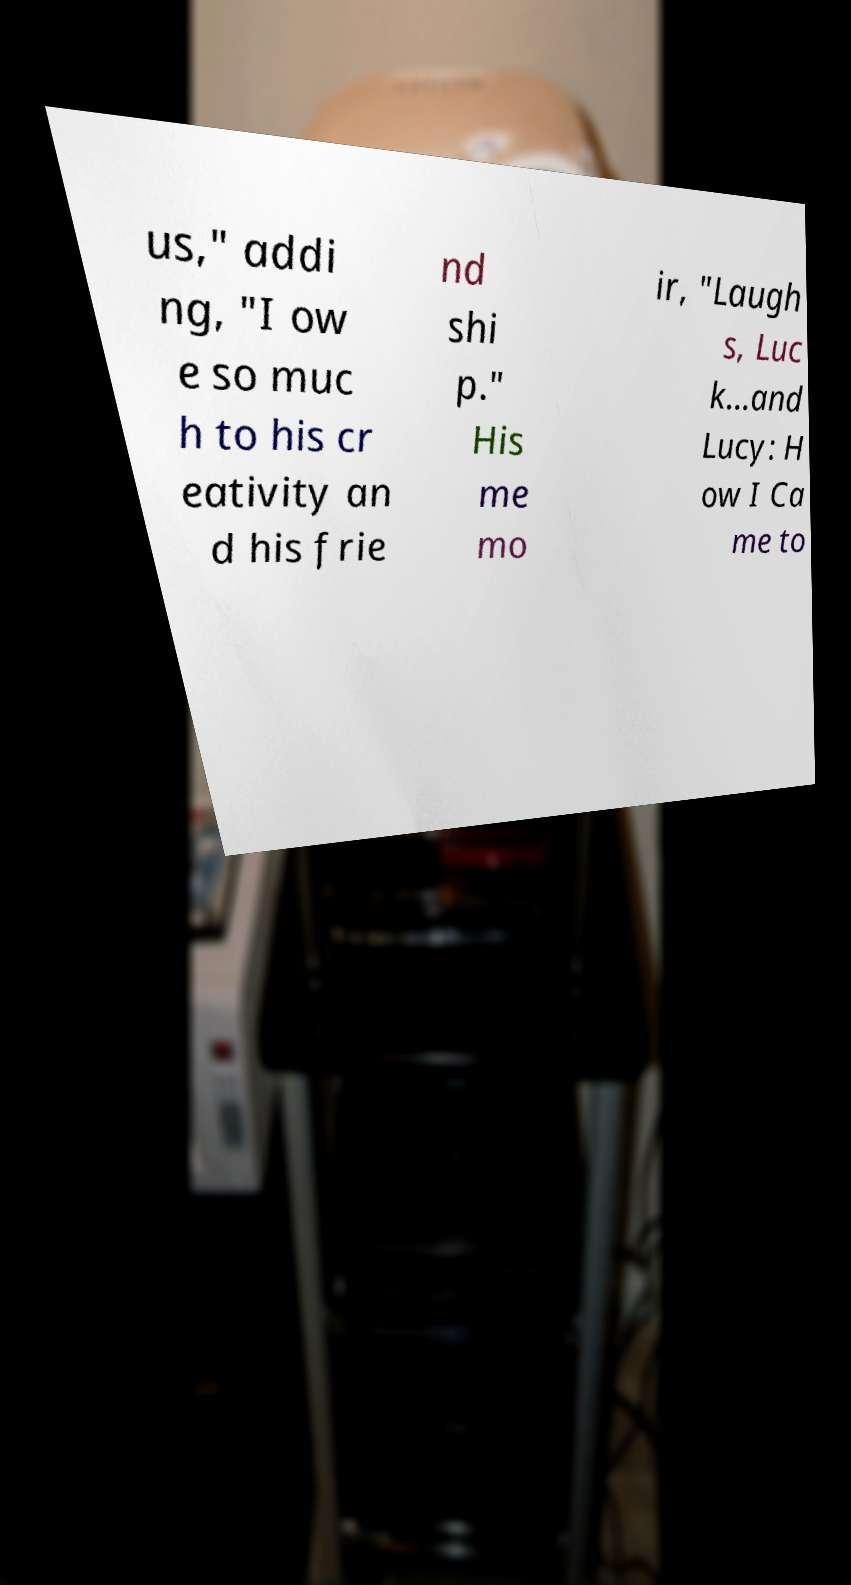Can you accurately transcribe the text from the provided image for me? us," addi ng, "I ow e so muc h to his cr eativity an d his frie nd shi p." His me mo ir, "Laugh s, Luc k...and Lucy: H ow I Ca me to 